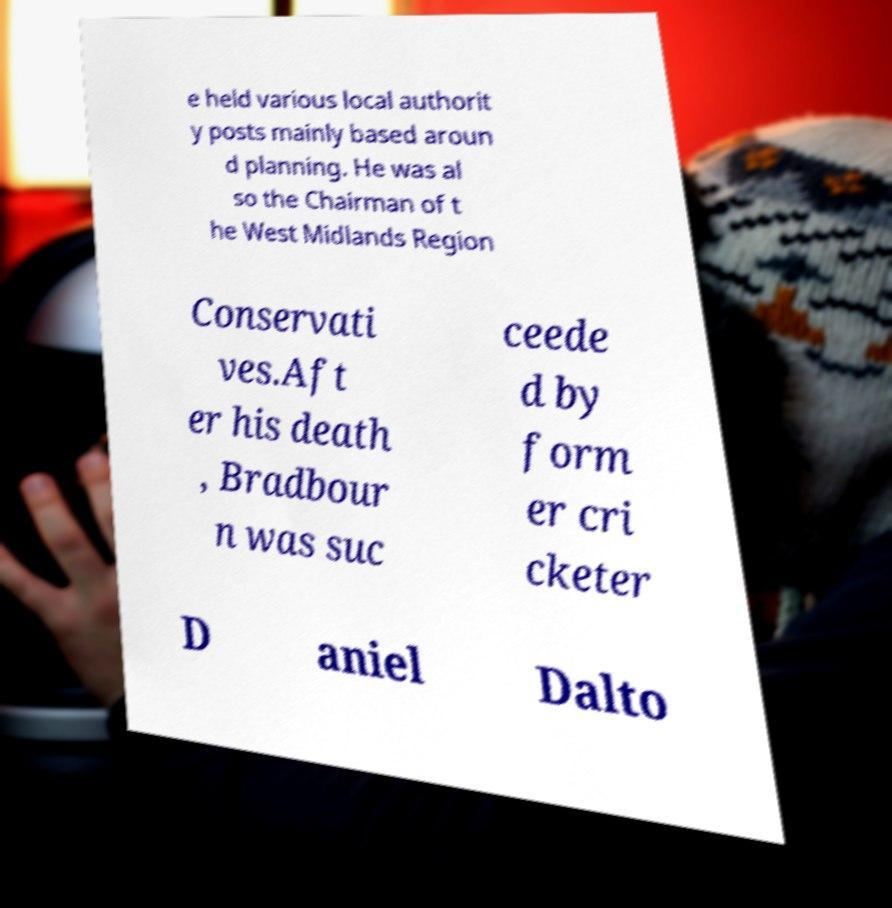Can you read and provide the text displayed in the image?This photo seems to have some interesting text. Can you extract and type it out for me? e held various local authorit y posts mainly based aroun d planning. He was al so the Chairman of t he West Midlands Region Conservati ves.Aft er his death , Bradbour n was suc ceede d by form er cri cketer D aniel Dalto 